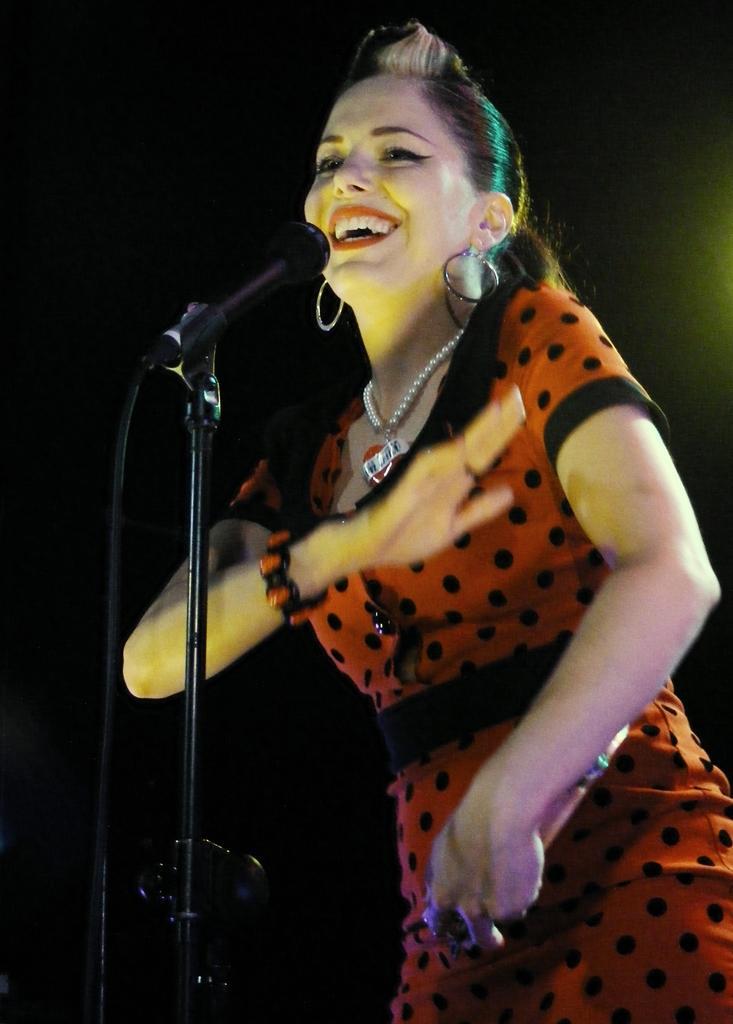How would you summarize this image in a sentence or two? In this picture I can see a tripod in front on which there is mic and I can see a woman in front of the tripod and I see that she is smiling and she is wearing red and black color dress. I see that it is dark in the background. 